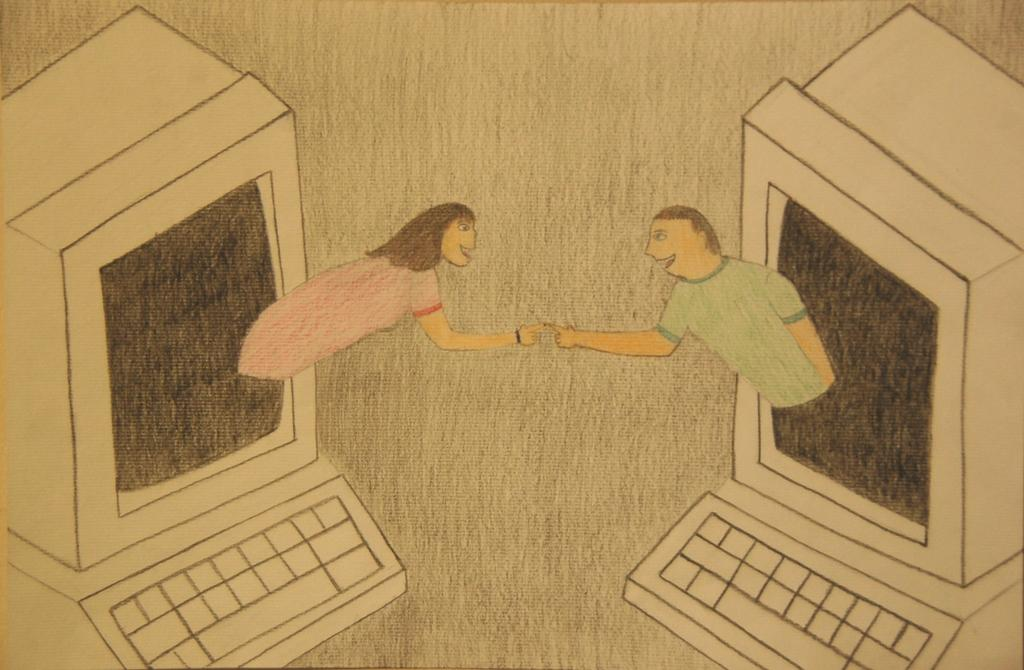What is the main subject of the painting in the image? The painting depicts a couple. What is the couple doing in the painting? The couple is coming out of a desktop in the painting. Where are the desktops located in the image? The desktops are in the left and right corners of the image. What other object is present below the desktop in the image? There is a keyboard below the desktop in the image. What type of smell is associated with the painting in the image? There is no smell associated with the painting in the image, as it is a visual representation and not a physical object. 